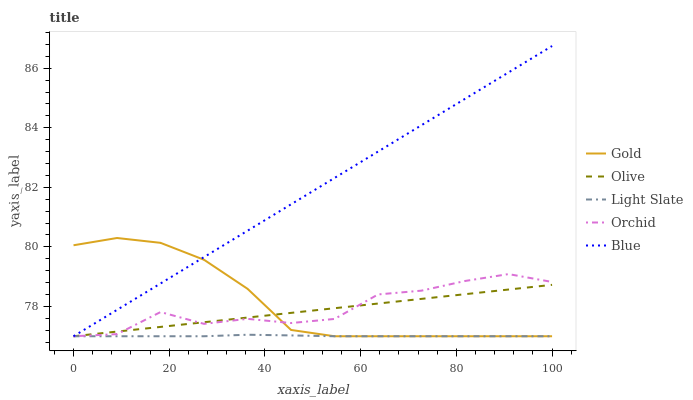Does Light Slate have the minimum area under the curve?
Answer yes or no. Yes. Does Blue have the maximum area under the curve?
Answer yes or no. Yes. Does Blue have the minimum area under the curve?
Answer yes or no. No. Does Light Slate have the maximum area under the curve?
Answer yes or no. No. Is Blue the smoothest?
Answer yes or no. Yes. Is Orchid the roughest?
Answer yes or no. Yes. Is Light Slate the smoothest?
Answer yes or no. No. Is Light Slate the roughest?
Answer yes or no. No. Does Olive have the lowest value?
Answer yes or no. Yes. Does Blue have the highest value?
Answer yes or no. Yes. Does Light Slate have the highest value?
Answer yes or no. No. Does Blue intersect Orchid?
Answer yes or no. Yes. Is Blue less than Orchid?
Answer yes or no. No. Is Blue greater than Orchid?
Answer yes or no. No. 